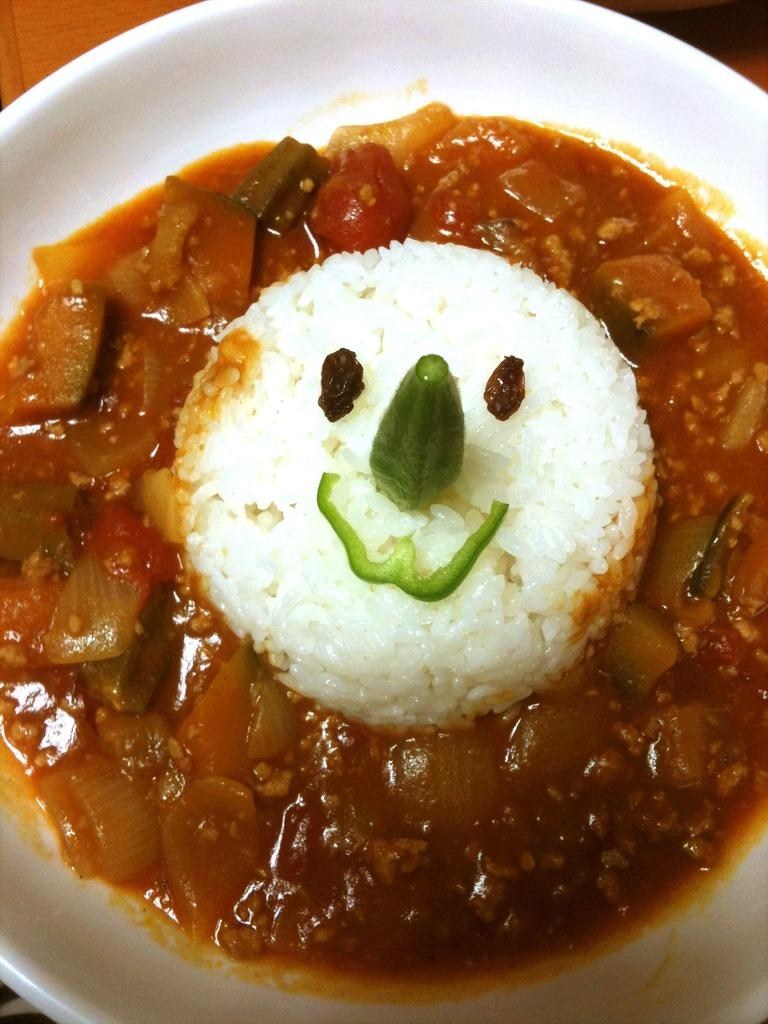What type of food item is present in the image? There is a food item containing rice in the image. What other ingredients are included in the food item? There are vegetables in the food item. How is the food item presented in the image? The food item is decorated in a white-colored container. What type of tongue can be seen sticking out of the container in the image? There is no tongue present in the image; it is a food item containing rice and vegetables in a white-colored container. 